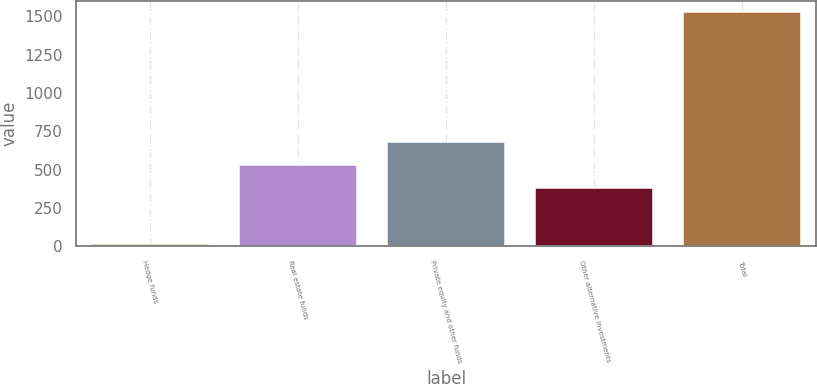<chart> <loc_0><loc_0><loc_500><loc_500><bar_chart><fcel>Hedge funds<fcel>Real estate funds<fcel>Private equity and other funds<fcel>Other alternative investments<fcel>Total<nl><fcel>14<fcel>532.3<fcel>683.6<fcel>381<fcel>1527<nl></chart> 